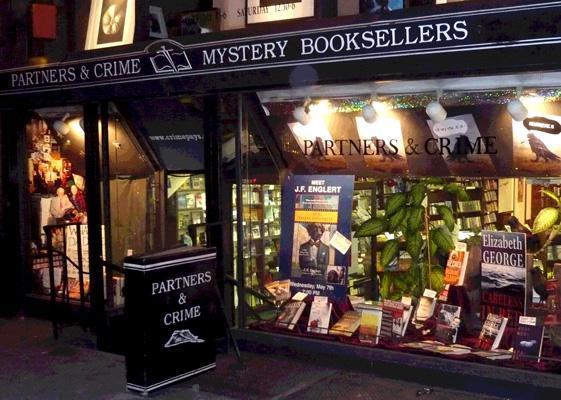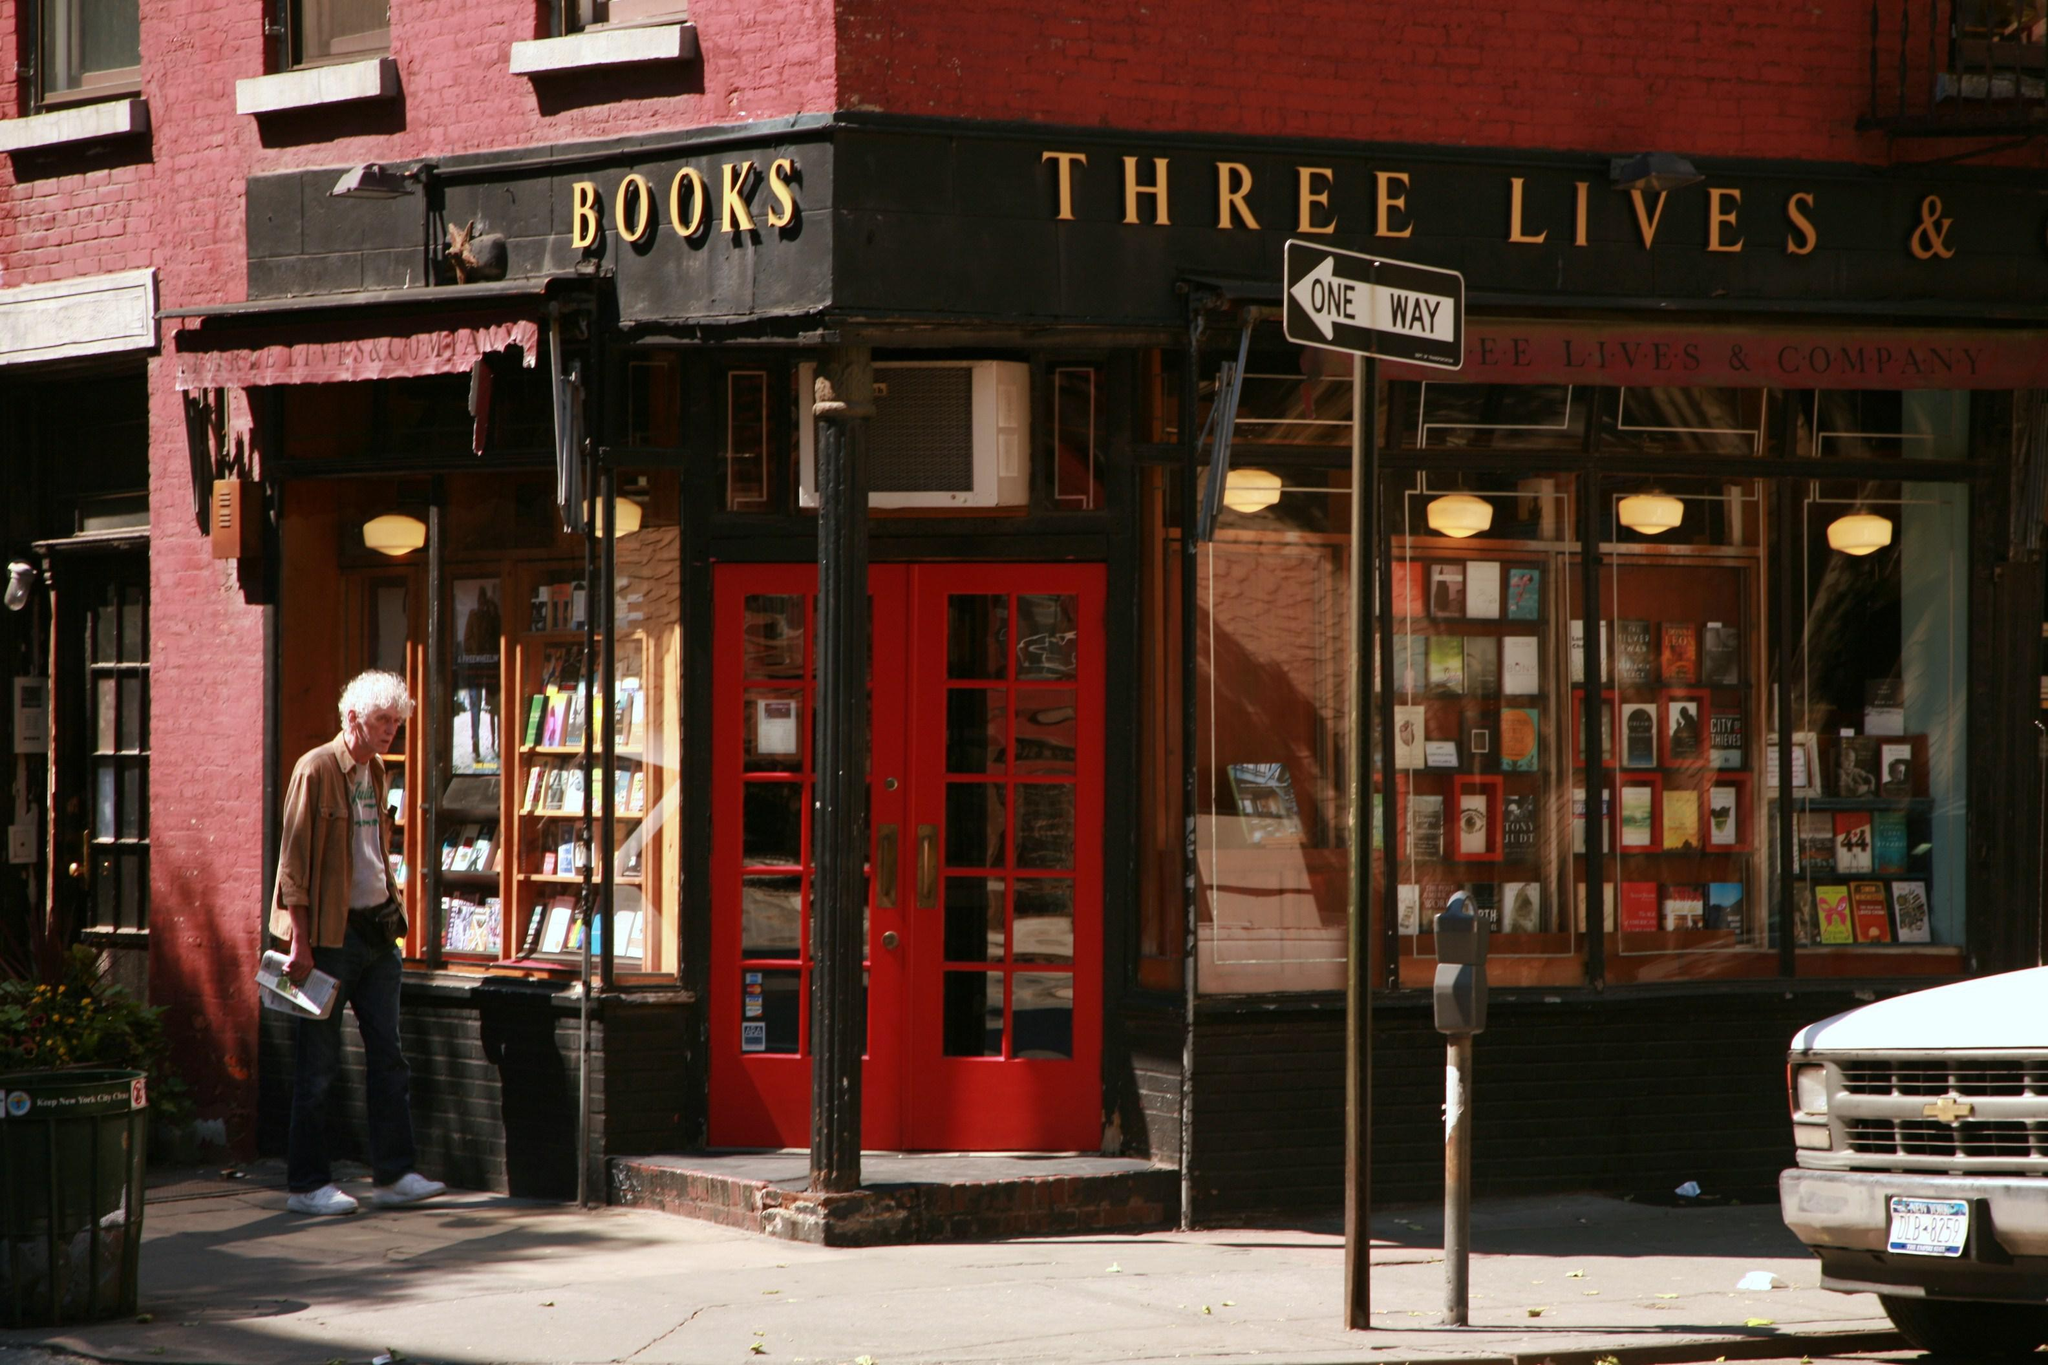The first image is the image on the left, the second image is the image on the right. Assess this claim about the two images: "In one image there is a bookstore on a street corner with a red door that is open.". Correct or not? Answer yes or no. No. The first image is the image on the left, the second image is the image on the right. Assess this claim about the two images: "There is one image taken of the inside of the bookstore". Correct or not? Answer yes or no. No. 